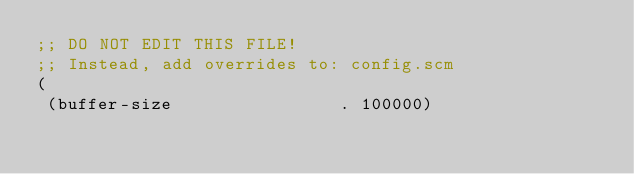<code> <loc_0><loc_0><loc_500><loc_500><_Scheme_>;; DO NOT EDIT THIS FILE!
;; Instead, add overrides to: config.scm
(
 (buffer-size                . 100000)</code> 